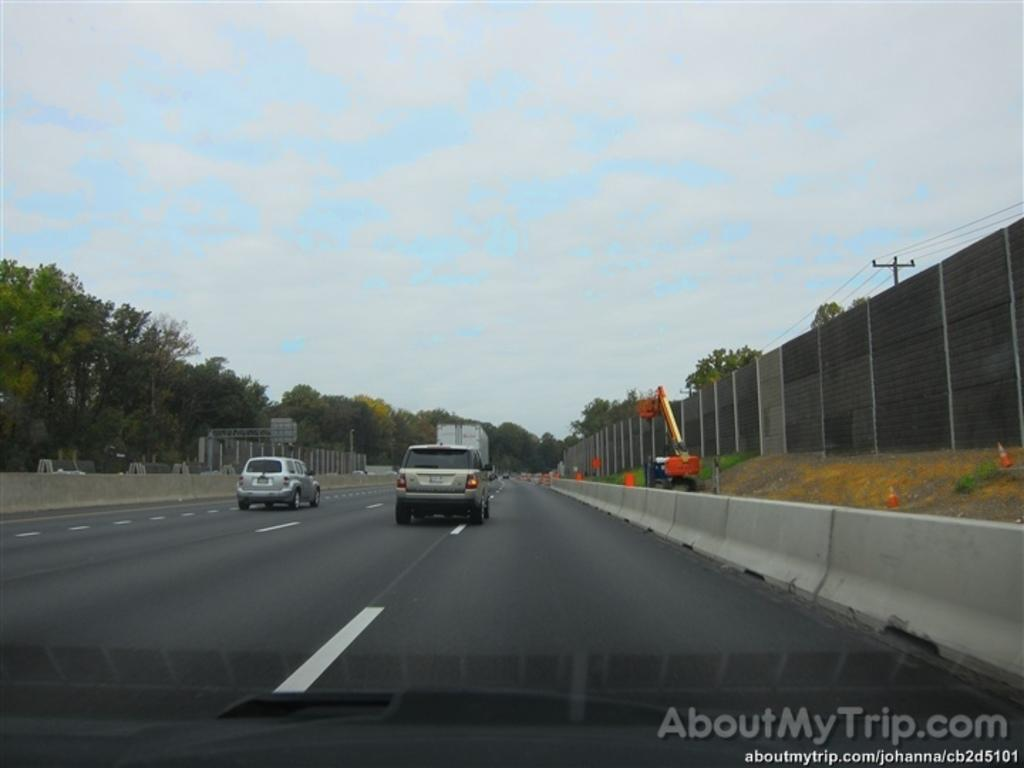Where was the image taken? The image was clicked outside. What can be seen in the middle of the image? There are trees and vehicles in the middle of the image. What is visible at the top of the image? The sky is visible at the top of the image. Can you see a girl teaching in the image? There is no girl teaching in the image. What type of fold can be seen in the image? There is no fold present in the image. 